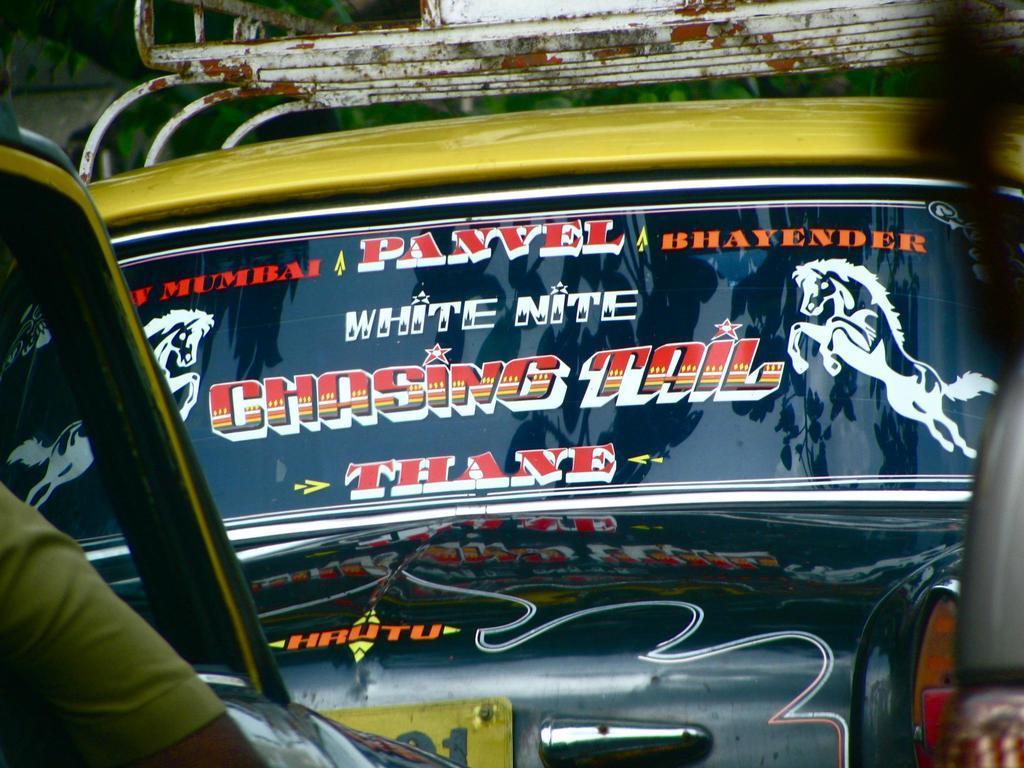How would you summarize this image in a sentence or two? In this image I can see few vehicles and few stickers attached to the glass. In front I can see the person's hand. 